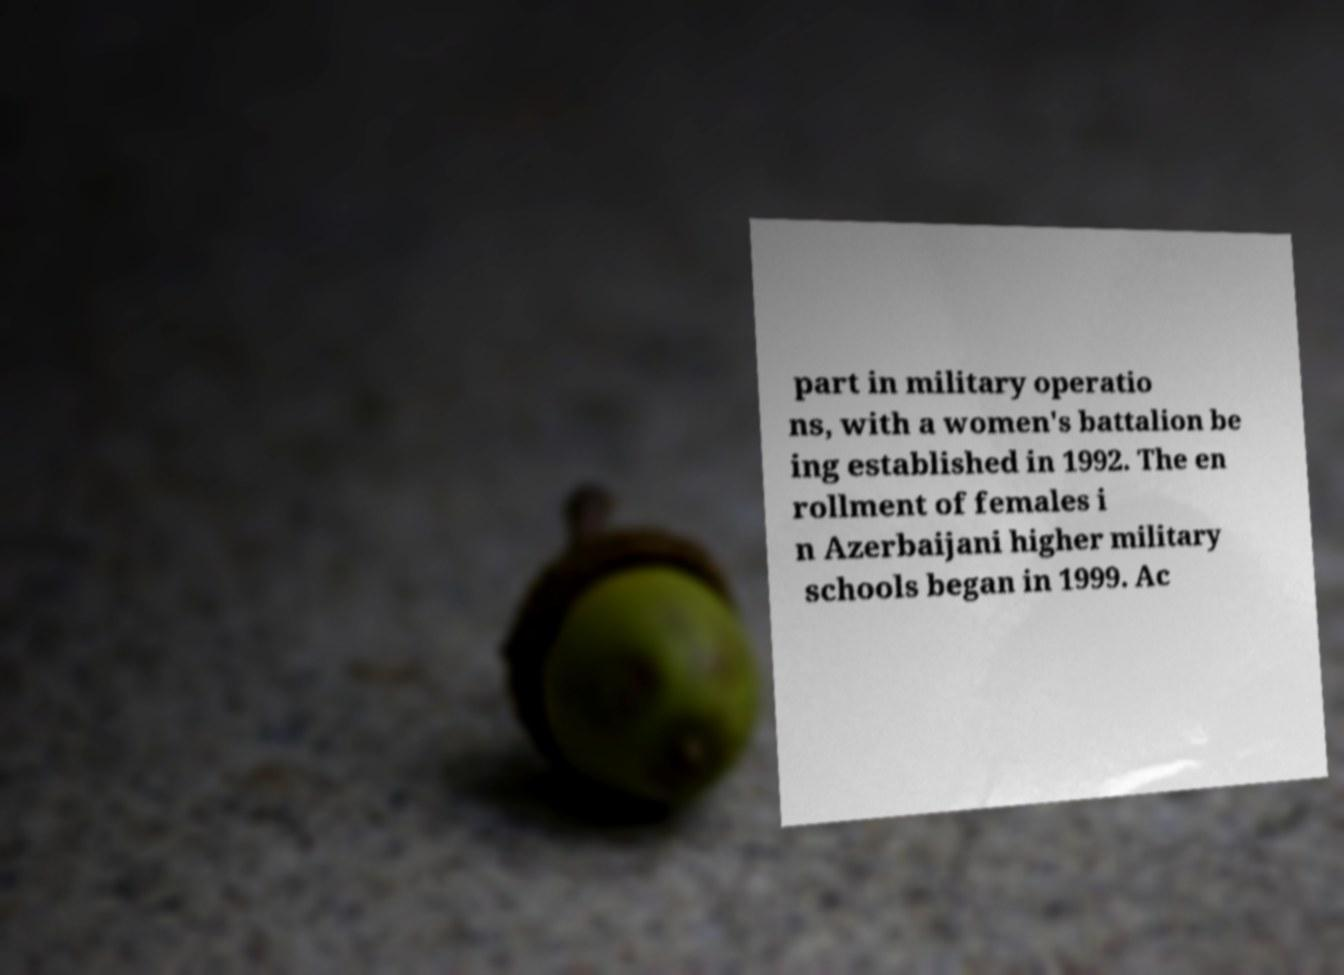Can you accurately transcribe the text from the provided image for me? part in military operatio ns, with a women's battalion be ing established in 1992. The en rollment of females i n Azerbaijani higher military schools began in 1999. Ac 